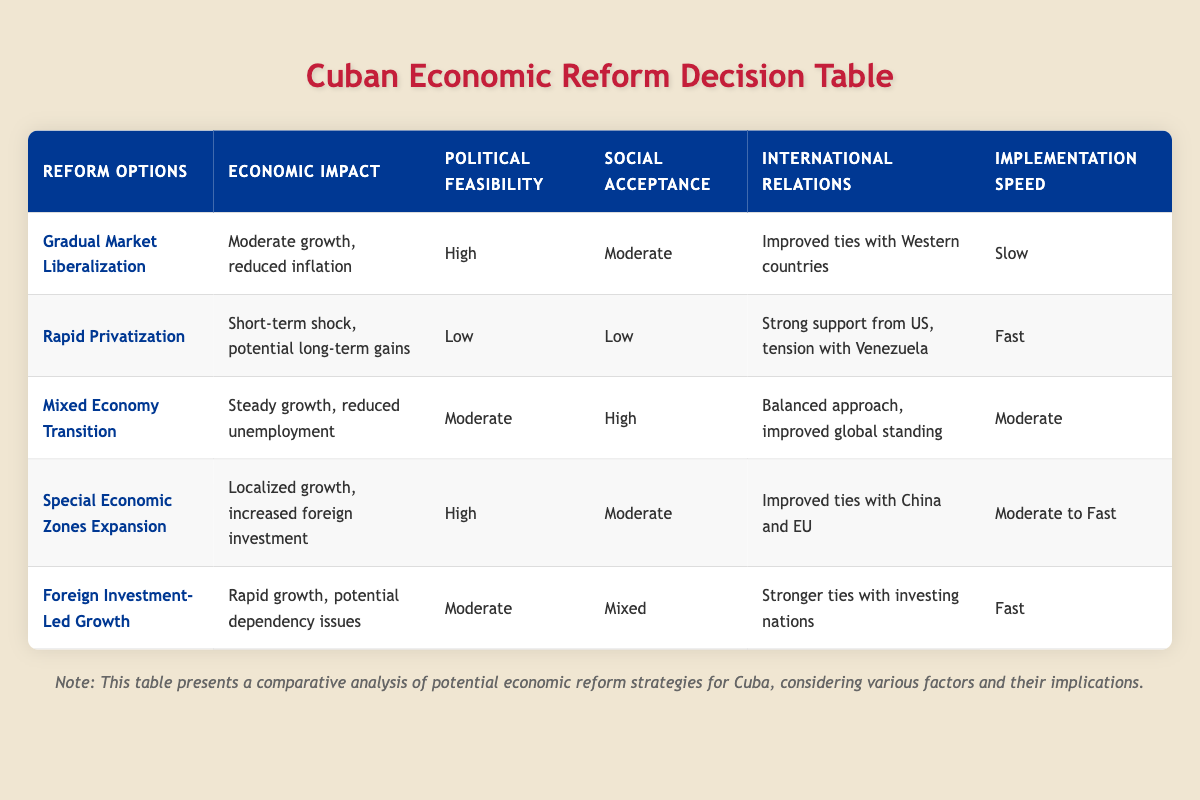What is the economic impact of Gradual Market Liberalization? According to the table, the economic impact of Gradual Market Liberalization is described as "Moderate growth, reduced inflation."
Answer: Moderate growth, reduced inflation Which reform option has the highest political feasibility? The reform option with the highest political feasibility is "Gradual Market Liberalization," which is rated as "High."
Answer: Gradual Market Liberalization Is the social acceptance for Rapid Privatization low? Yes, the table indicates that social acceptance for Rapid Privatization is rated as "Low."
Answer: Yes What is the implementation speed for Mixed Economy Transition compared to Rapid Privatization? The implementation speed for Mixed Economy Transition is rated as "Moderate," while for Rapid Privatization it is rated as "Fast." Therefore, Mixed Economy Transition is slower compared to Rapid Privatization.
Answer: Slower How many reform options have a moderate economic impact? Looking at each reform option's economic impact: Gradual Market Liberalization (Moderate), Mixed Economy Transition (Steady growth), Special Economic Zones Expansion (Localized growth), and Foreign Investment-Led Growth (Rapid growth) - only Gradual Market Liberalization and Mixed Economy Transition fit the description of moderate. Thus, there are 2 reform options with moderate economic impact.
Answer: 2 What are the international relations outcomes for Special Economic Zones Expansion and Foreign Investment-Led Growth? For Special Economic Zones Expansion, the outcome is "Improved ties with China and EU." In contrast, for Foreign Investment-Led Growth, the outcome is "Stronger ties with investing nations." Thus, they present different international relations outcomes.
Answer: Different outcomes Which reform option results in the fastest implementation speed? The table shows that both Rapid Privatization and Foreign Investment-Led Growth are categorized as having a "Fast" implementation speed. Therefore, they are tied for the fastest implementation speed.
Answer: Tied In terms of social acceptance, which reform option is the least accepted? Rapid Privatization has the lowest social acceptance rating at "Low," compared to other options that have moderate or high ratings.
Answer: Rapid Privatization What is the outcome of Foreign Investment-Led Growth regarding international relations? The outcome for Foreign Investment-Led Growth in terms of international relations is described as "Stronger ties with investing nations."
Answer: Stronger ties with investing nations 